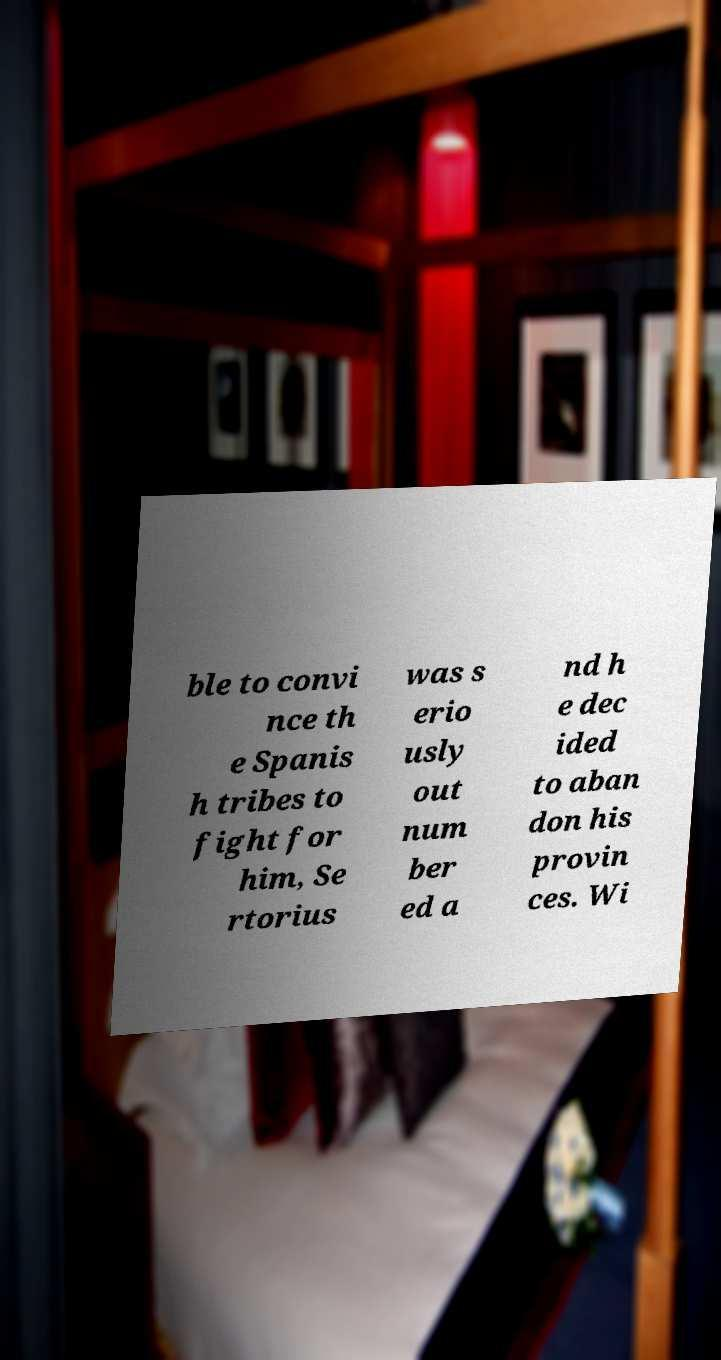Can you read and provide the text displayed in the image?This photo seems to have some interesting text. Can you extract and type it out for me? ble to convi nce th e Spanis h tribes to fight for him, Se rtorius was s erio usly out num ber ed a nd h e dec ided to aban don his provin ces. Wi 